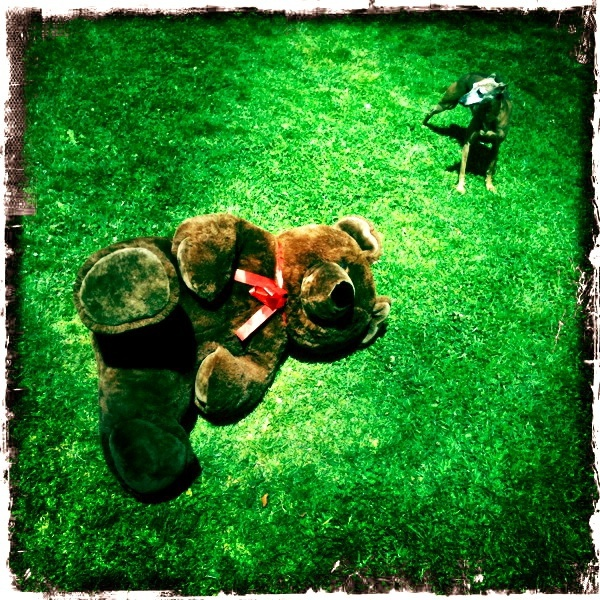Describe the objects in this image and their specific colors. I can see teddy bear in white, black, darkgreen, and olive tones, teddy bear in white, black, olive, and darkgreen tones, teddy bear in white, black, olive, and darkgreen tones, and dog in white, black, darkgreen, ivory, and green tones in this image. 